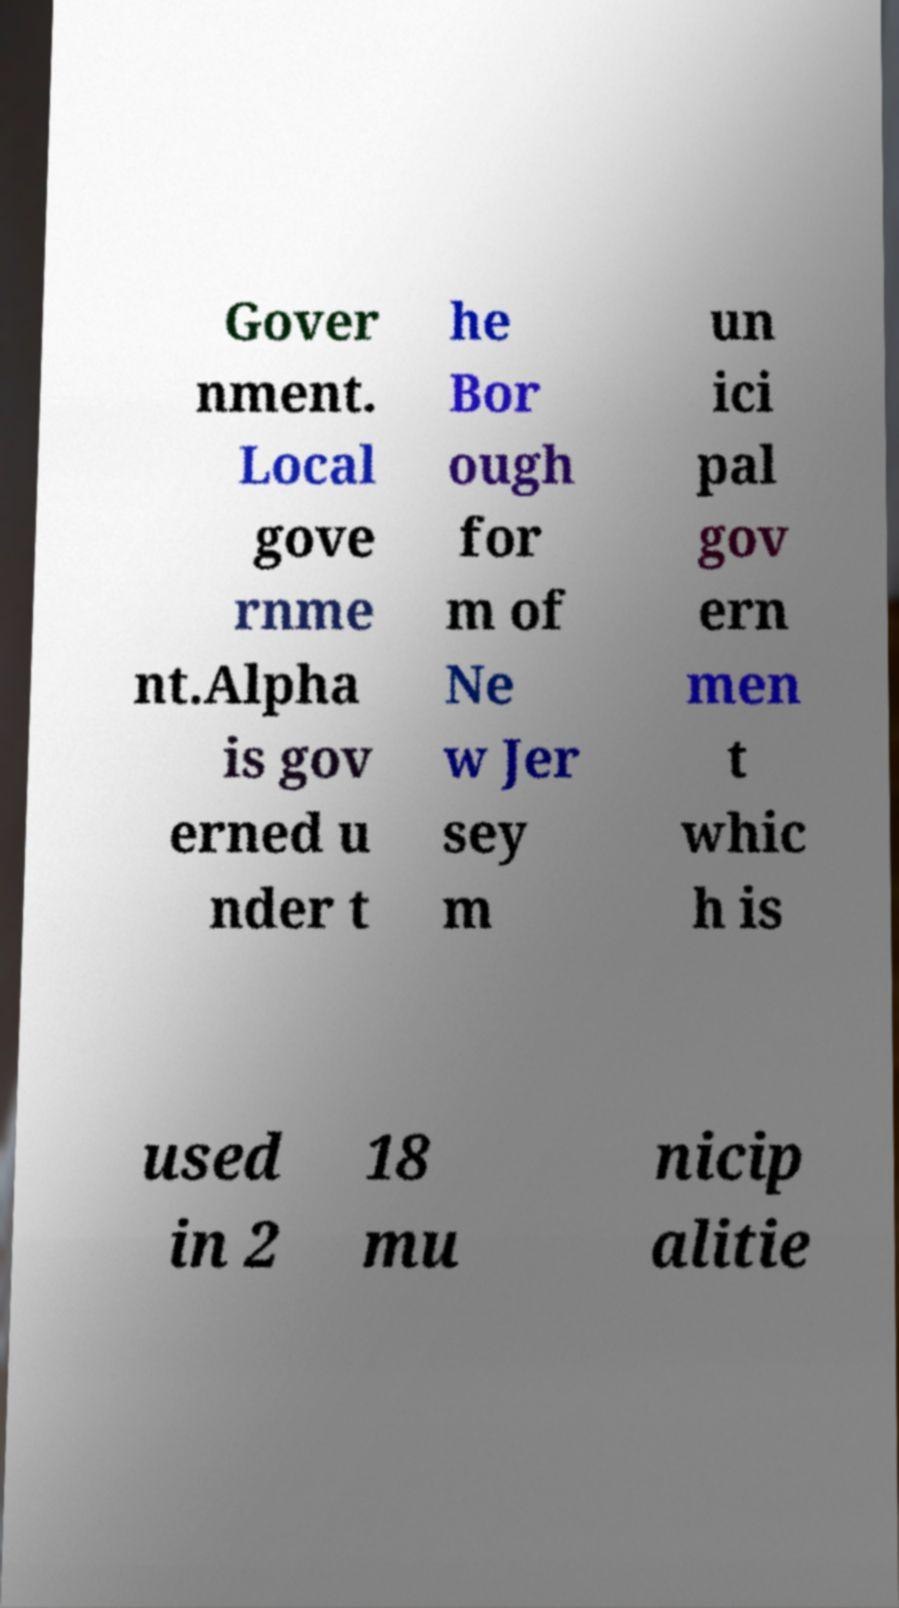Could you extract and type out the text from this image? Gover nment. Local gove rnme nt.Alpha is gov erned u nder t he Bor ough for m of Ne w Jer sey m un ici pal gov ern men t whic h is used in 2 18 mu nicip alitie 